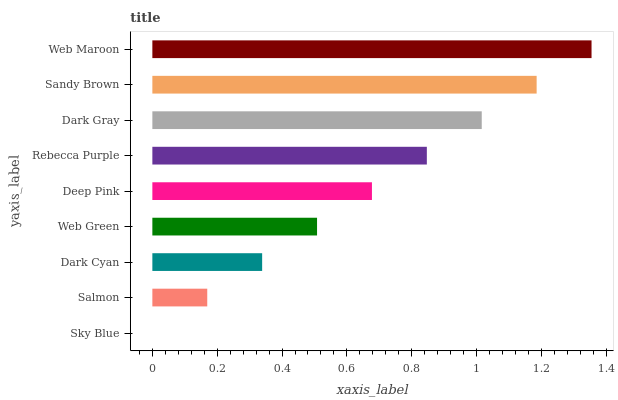Is Sky Blue the minimum?
Answer yes or no. Yes. Is Web Maroon the maximum?
Answer yes or no. Yes. Is Salmon the minimum?
Answer yes or no. No. Is Salmon the maximum?
Answer yes or no. No. Is Salmon greater than Sky Blue?
Answer yes or no. Yes. Is Sky Blue less than Salmon?
Answer yes or no. Yes. Is Sky Blue greater than Salmon?
Answer yes or no. No. Is Salmon less than Sky Blue?
Answer yes or no. No. Is Deep Pink the high median?
Answer yes or no. Yes. Is Deep Pink the low median?
Answer yes or no. Yes. Is Sky Blue the high median?
Answer yes or no. No. Is Sky Blue the low median?
Answer yes or no. No. 